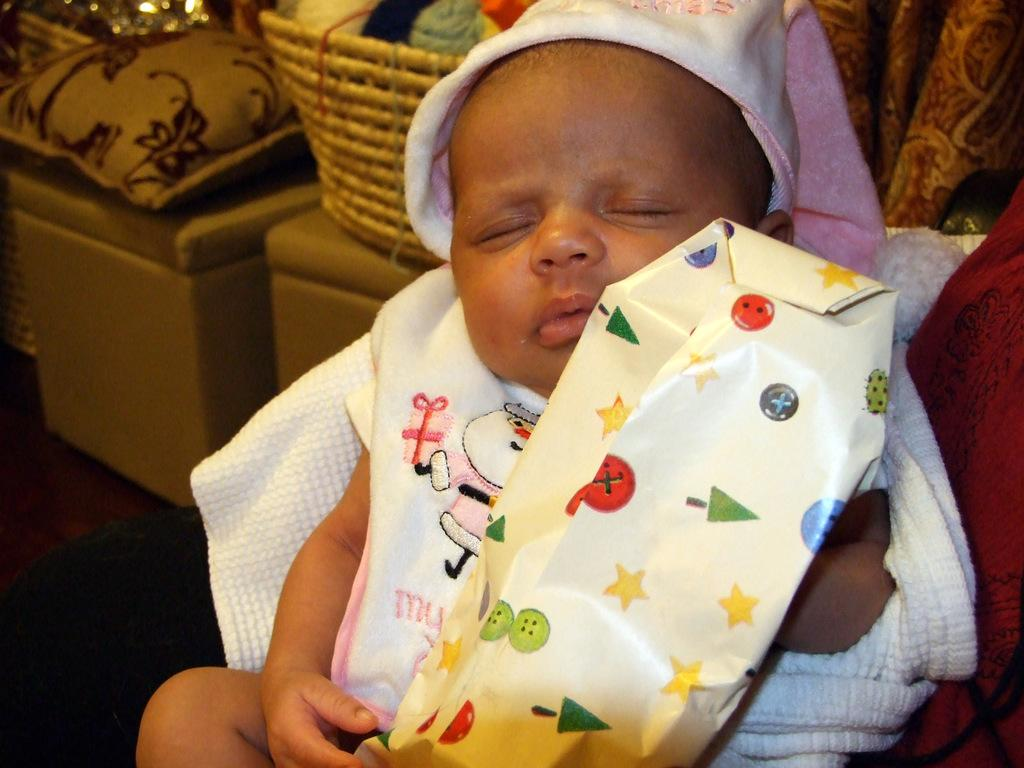What is the main subject of the image? The main subject of the image is a baby sleeping. What is the baby holding in the image? The baby is holding a packet in the image. What object is present in the image that might be used for carrying items? There is a basket in the image that could be used for carrying items. What object is present in the image that might provide comfort to the baby? There is a pillow in the image that could provide comfort to the baby. What type of furniture is present in the image? Chairs are present in the image. What type of space suit is the baby wearing in the image? There is no space suit present in the image; the baby is simply sleeping and holding a packet. 